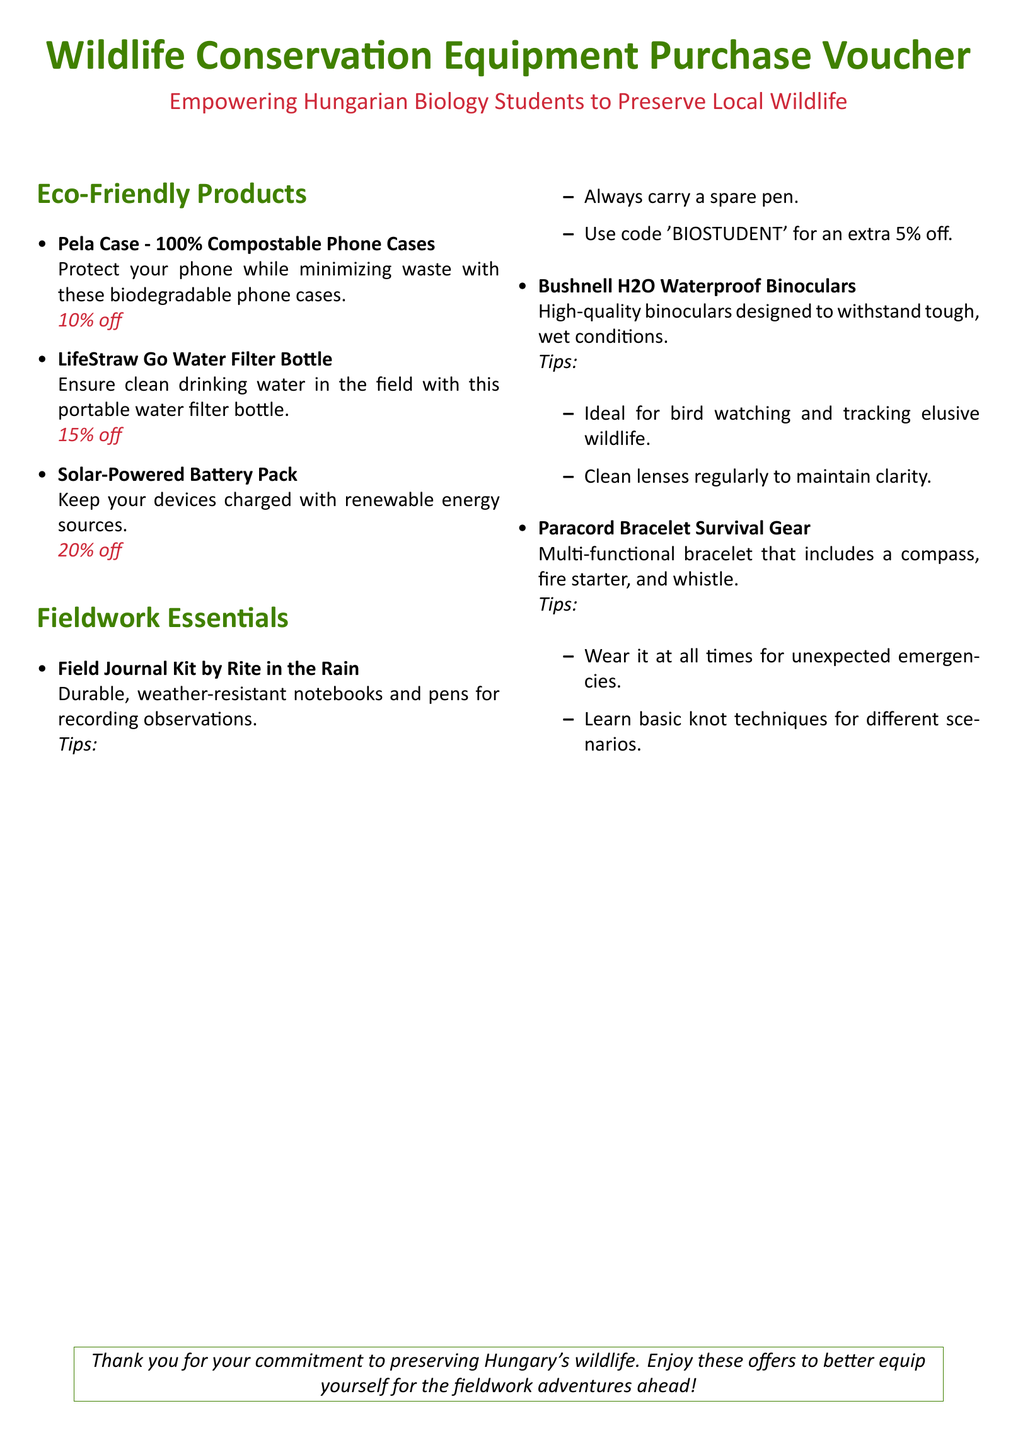What is the discount on the Pela Case? The Pela Case has a discount rate of 10% off as mentioned in the document.
Answer: 10% off What product helps ensure clean drinking water? The document specifies the LifeStraw Go Water Filter Bottle as a product that provides clean drinking water in the field.
Answer: LifeStraw Go Water Filter Bottle What are the tips for using the Field Journal Kit? The tips suggest carrying a spare pen and using code 'BIOSTUDENT' for an extra discount when purchasing the Field Journal Kit.
Answer: Carry a spare pen What is the discount on the Solar-Powered Battery Pack? The document states that the Solar-Powered Battery Pack has a discount rate of 20% off.
Answer: 20% off Which product includes survival gear? The Paracord Bracelet is the product mentioned in the document that includes survival gear.
Answer: Paracord Bracelet What should be done regularly to maintain the binoculars? The document advises to clean the lenses regularly to maintain clarity for the Bushnell H2O Waterproof Binoculars.
Answer: Clean lenses regularly What is the purpose of the voucher? The purpose of the voucher is to empower Hungarian Biology Students to preserve local wildlife while providing discounts on eco-friendly products.
Answer: Empowering Hungarian Biology Students How much extra discount can be obtained using the code for the Field Journal Kit? The code offers an extra discount of 5% off when used for the Field Journal Kit purchase.
Answer: 5% off 